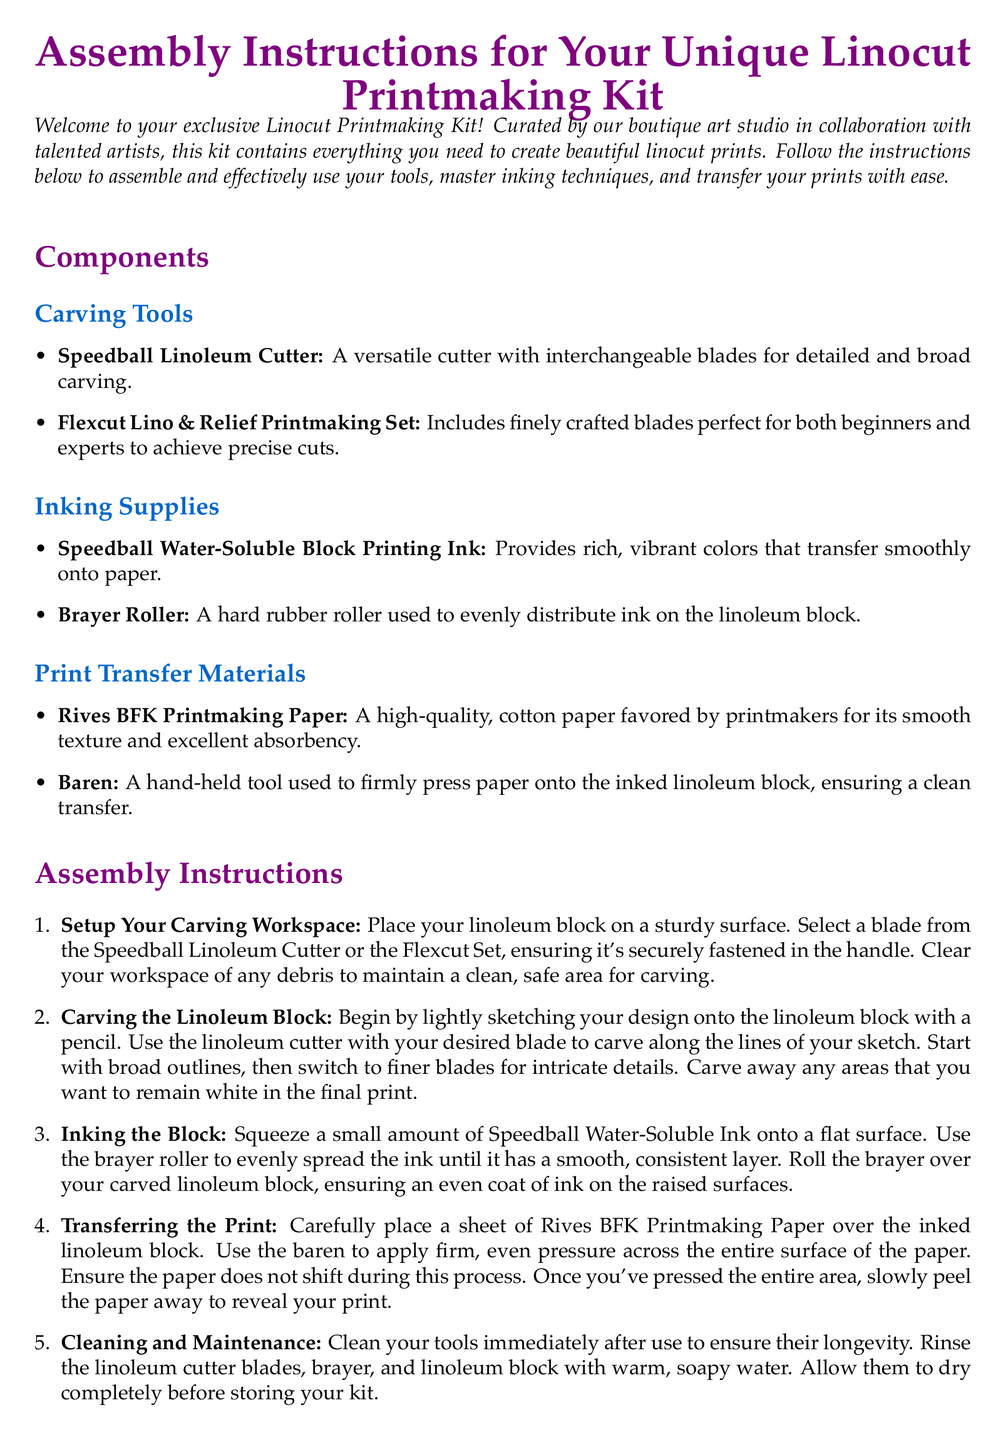What is the name of the cutting tool included in the kit? The document explicitly mentions the "Speedball Linoleum Cutter" as a cutting tool in the kit.
Answer: Speedball Linoleum Cutter How many types of inking supplies are mentioned? The document lists two specific inking supplies: Speedball Water-Soluble Block Printing Ink and Brayer Roller.
Answer: 2 Which paper is recommended for printmaking? The document identifies "Rives BFK Printmaking Paper" as the recommended paper for printmaking.
Answer: Rives BFK Printmaking Paper What is the purpose of the baren in the printmaking process? The baren is described in the document as a tool used to apply pressure for transferring prints, indicating its essential role during this phase.
Answer: Press paper What step follows inking the block? In the sequential assembly instructions, the step that follows inking the block is transferring the print onto paper.
Answer: Transferring the Print What should you do immediately after using your tools? The instructions emphasize the importance of cleaning the tools immediately after use to maintain their condition.
Answer: Clean tools What type of ink is listed in the kit? The document specifies "Water-Soluble Block Printing Ink" which indicates the type of ink included in the kit.
Answer: Water-Soluble Block Printing Ink What tool should be used to evenly distribute ink? The document mentions using a "Brayer Roller" to ensure an even distribution of ink on the linoleum block.
Answer: Brayer Roller What must be done to the linoleum cutter blades after use? The cleaning instructions highlight that the linoleum cutter blades need to be rinsed after use for maintenance.
Answer: Rinse blades 